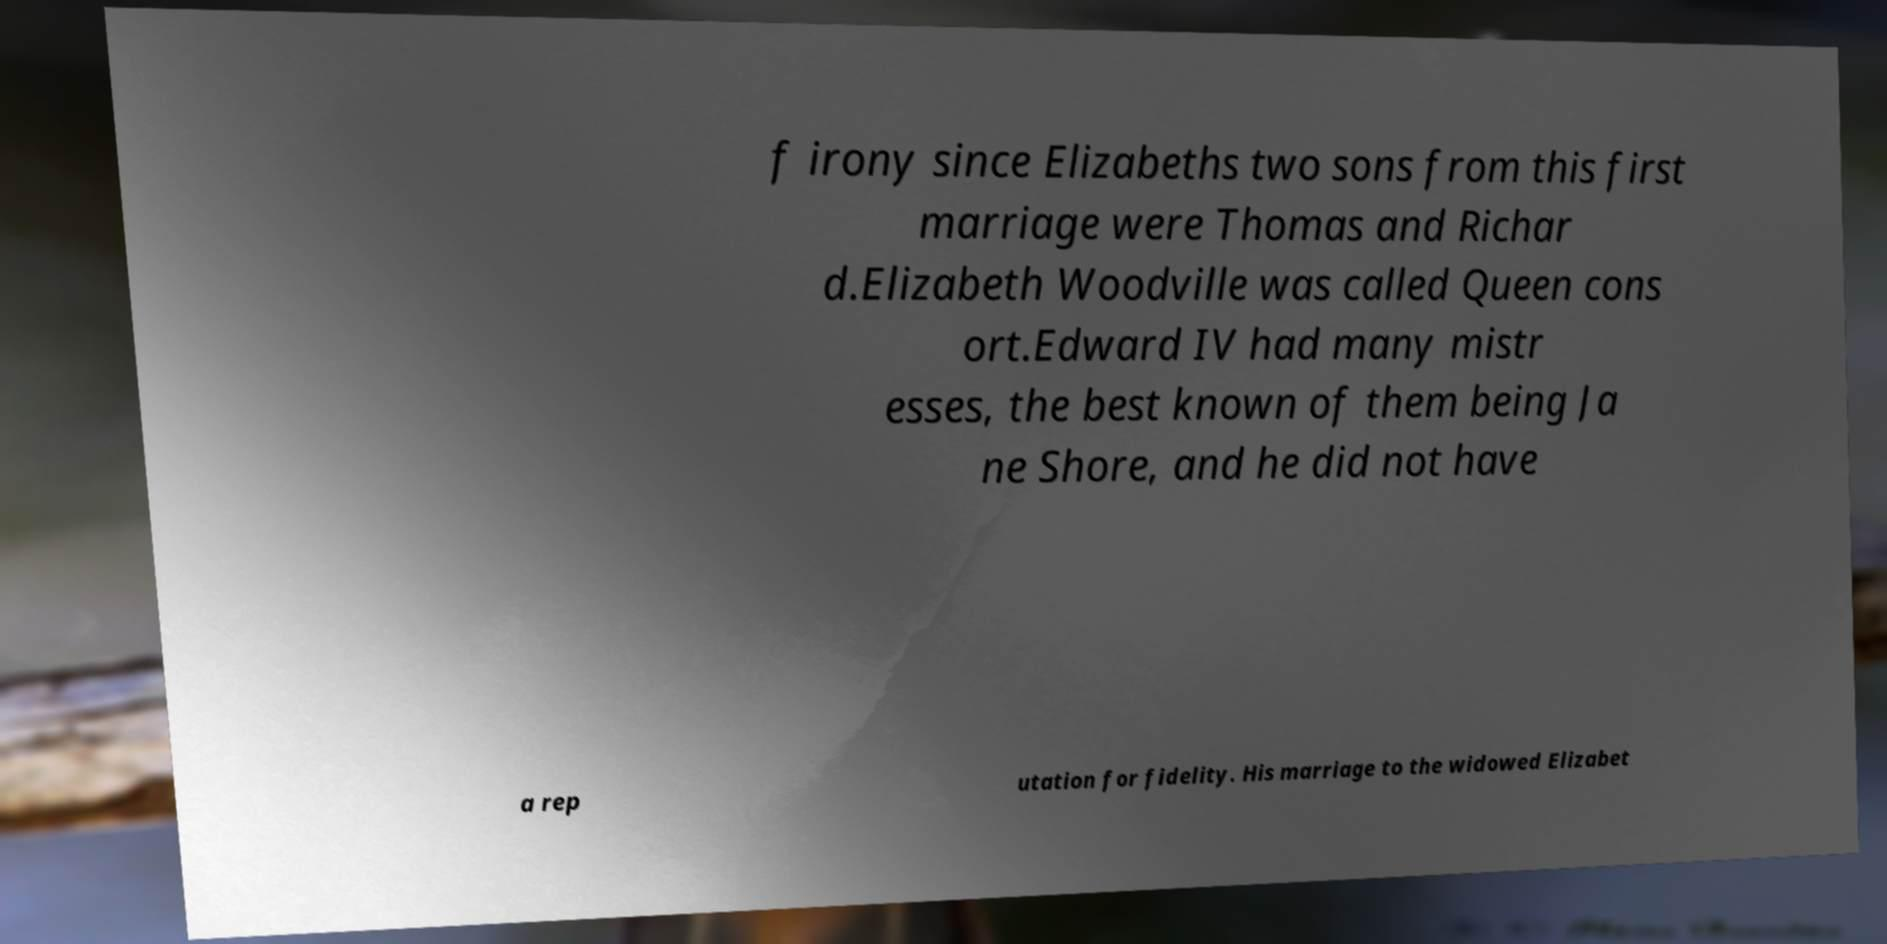What messages or text are displayed in this image? I need them in a readable, typed format. f irony since Elizabeths two sons from this first marriage were Thomas and Richar d.Elizabeth Woodville was called Queen cons ort.Edward IV had many mistr esses, the best known of them being Ja ne Shore, and he did not have a rep utation for fidelity. His marriage to the widowed Elizabet 